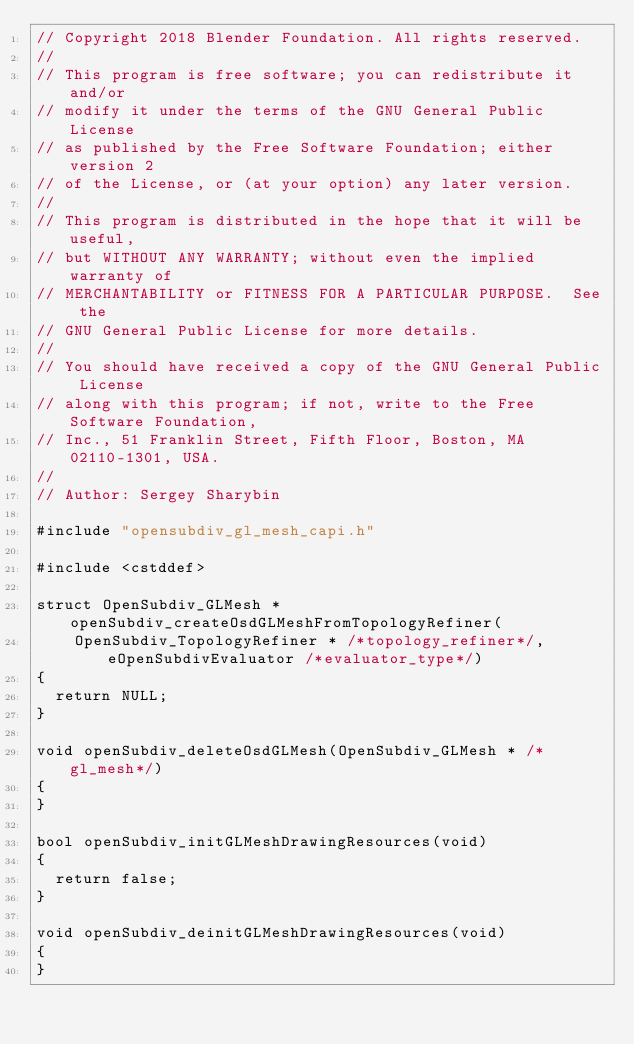<code> <loc_0><loc_0><loc_500><loc_500><_C++_>// Copyright 2018 Blender Foundation. All rights reserved.
//
// This program is free software; you can redistribute it and/or
// modify it under the terms of the GNU General Public License
// as published by the Free Software Foundation; either version 2
// of the License, or (at your option) any later version.
//
// This program is distributed in the hope that it will be useful,
// but WITHOUT ANY WARRANTY; without even the implied warranty of
// MERCHANTABILITY or FITNESS FOR A PARTICULAR PURPOSE.  See the
// GNU General Public License for more details.
//
// You should have received a copy of the GNU General Public License
// along with this program; if not, write to the Free Software Foundation,
// Inc., 51 Franklin Street, Fifth Floor, Boston, MA 02110-1301, USA.
//
// Author: Sergey Sharybin

#include "opensubdiv_gl_mesh_capi.h"

#include <cstddef>

struct OpenSubdiv_GLMesh *openSubdiv_createOsdGLMeshFromTopologyRefiner(
    OpenSubdiv_TopologyRefiner * /*topology_refiner*/, eOpenSubdivEvaluator /*evaluator_type*/)
{
  return NULL;
}

void openSubdiv_deleteOsdGLMesh(OpenSubdiv_GLMesh * /*gl_mesh*/)
{
}

bool openSubdiv_initGLMeshDrawingResources(void)
{
  return false;
}

void openSubdiv_deinitGLMeshDrawingResources(void)
{
}
</code> 